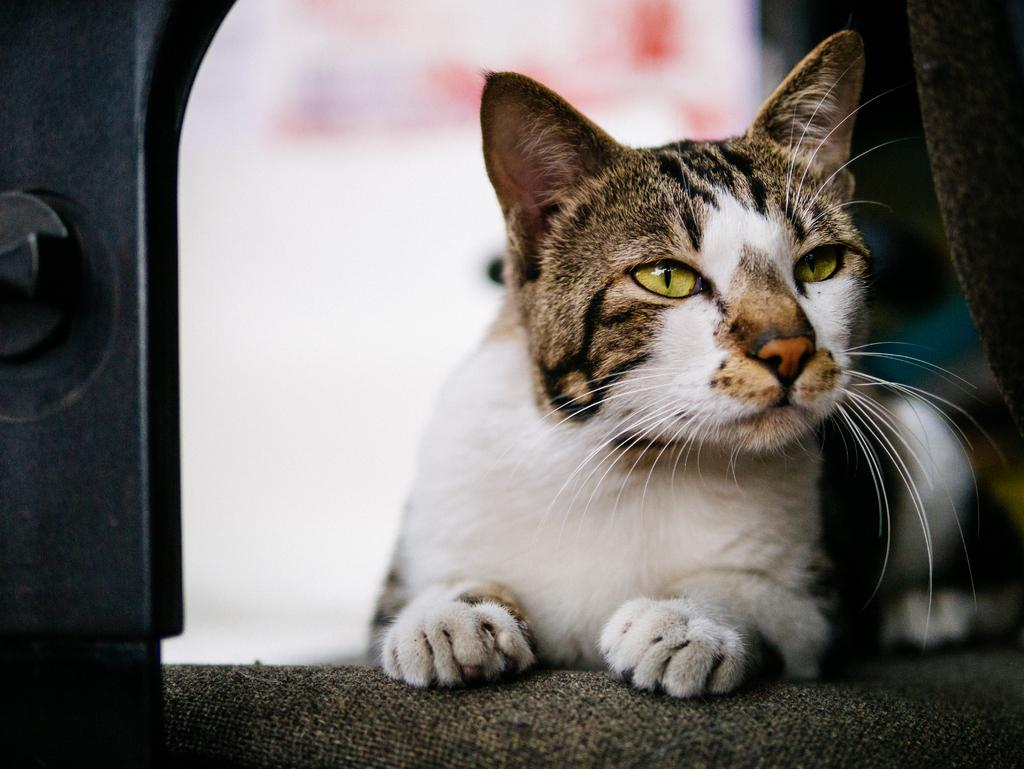What animal is present in the picture? There is a cat in the picture. What is the cat sitting on? The cat is sitting on a mat surface. What is the color of the cat? The cat is white in color. Are there any distinct markings on the cat? Yes, the cat has black lines on it. What type of wrench is the cat using to fix the car in the image? There is no wrench or car present in the image; it features a white cat with black lines sitting on a mat. Can you see the cat swinging on a swing in the image? There is no swing present in the image; the cat is sitting on a mat. 